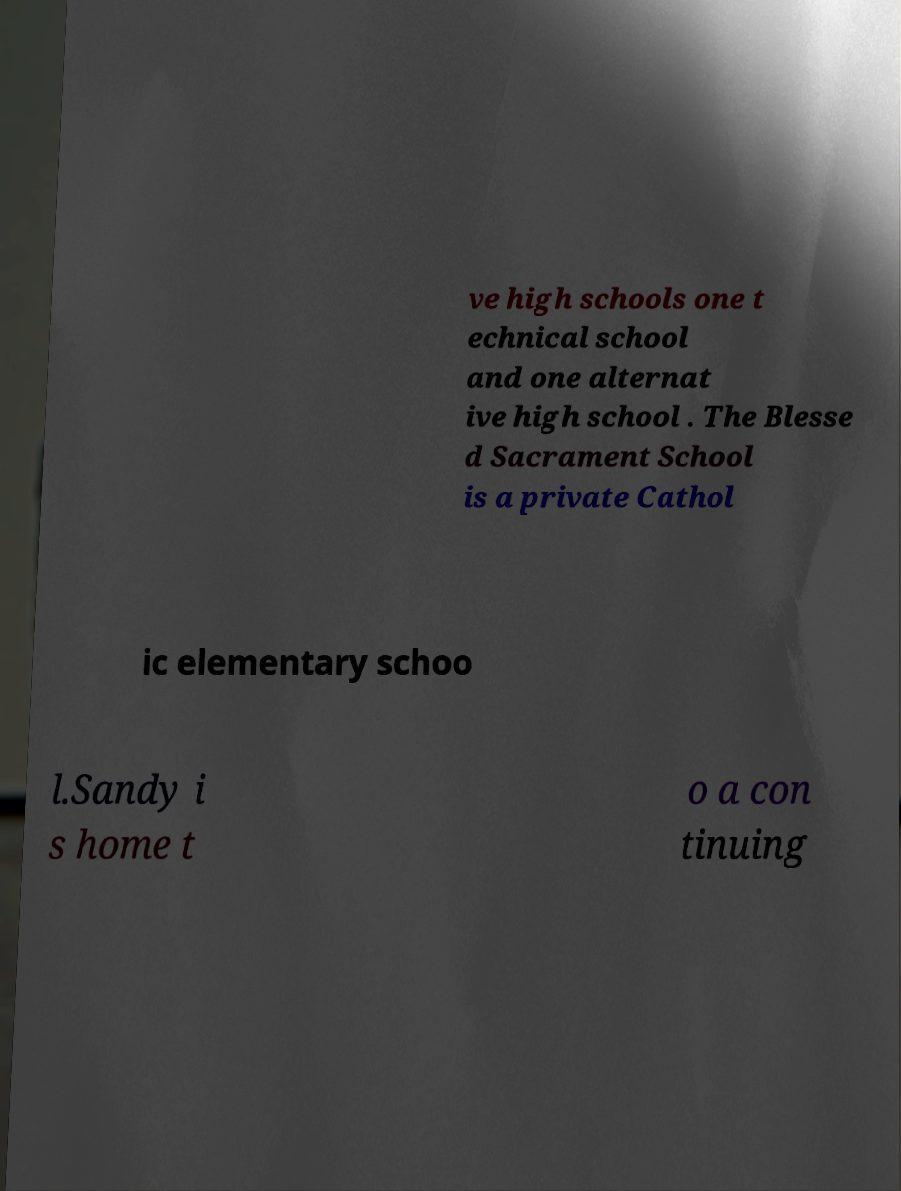Please read and relay the text visible in this image. What does it say? ve high schools one t echnical school and one alternat ive high school . The Blesse d Sacrament School is a private Cathol ic elementary schoo l.Sandy i s home t o a con tinuing 